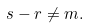Convert formula to latex. <formula><loc_0><loc_0><loc_500><loc_500>s - r \neq m .</formula> 